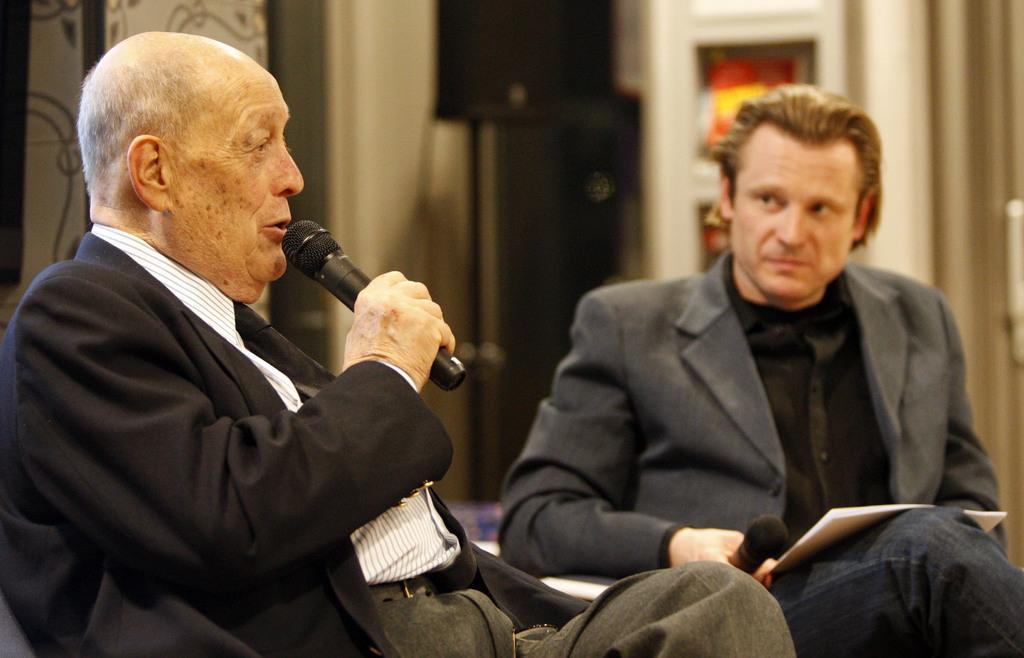In one or two sentences, can you explain what this image depicts? There are two persons sitting on the chairs. This man is holding a mike and talking and the other man is holding a man and some papers on his lap. At background I can see a black color object and i think this is a door. 